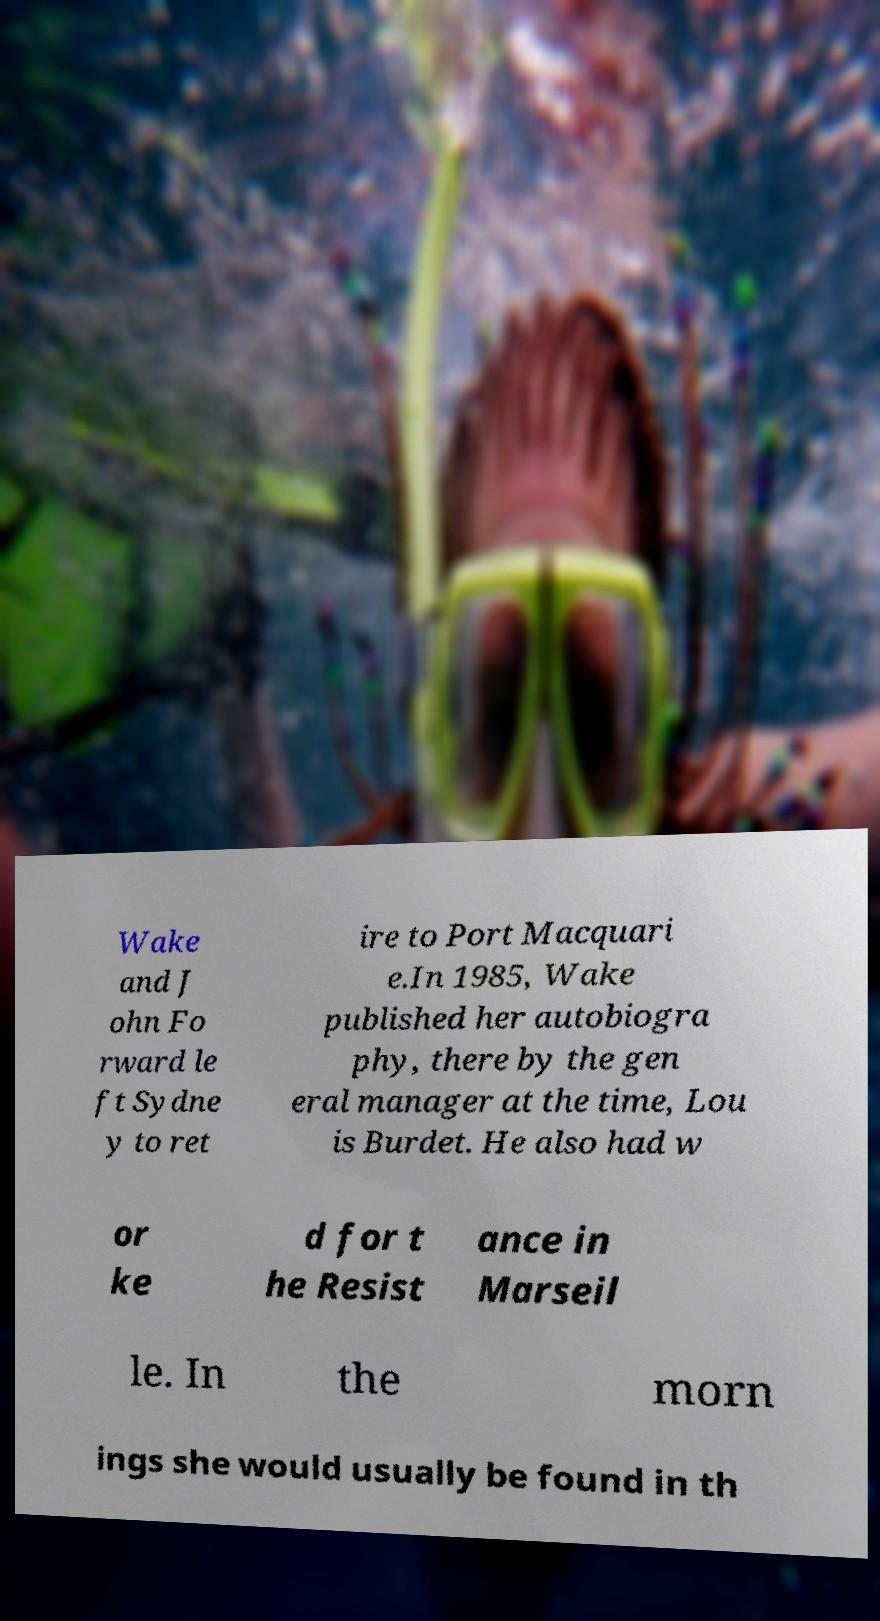Could you assist in decoding the text presented in this image and type it out clearly? Wake and J ohn Fo rward le ft Sydne y to ret ire to Port Macquari e.In 1985, Wake published her autobiogra phy, there by the gen eral manager at the time, Lou is Burdet. He also had w or ke d for t he Resist ance in Marseil le. In the morn ings she would usually be found in th 